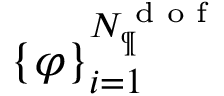<formula> <loc_0><loc_0><loc_500><loc_500>\{ \varphi \} _ { i = 1 } ^ { N _ { \P } ^ { d o f } }</formula> 